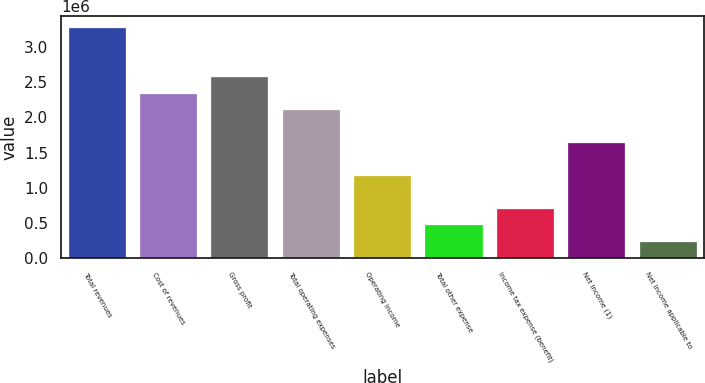Convert chart. <chart><loc_0><loc_0><loc_500><loc_500><bar_chart><fcel>Total revenues<fcel>Cost of revenues<fcel>Gross profit<fcel>Total operating expenses<fcel>Operating income<fcel>Total other expense<fcel>Income tax expense (benefit)<fcel>Net income (1)<fcel>Net income applicable to<nl><fcel>3.27349e+06<fcel>2.33821e+06<fcel>2.57203e+06<fcel>2.10439e+06<fcel>1.16911e+06<fcel>467650<fcel>701471<fcel>1.63675e+06<fcel>233830<nl></chart> 